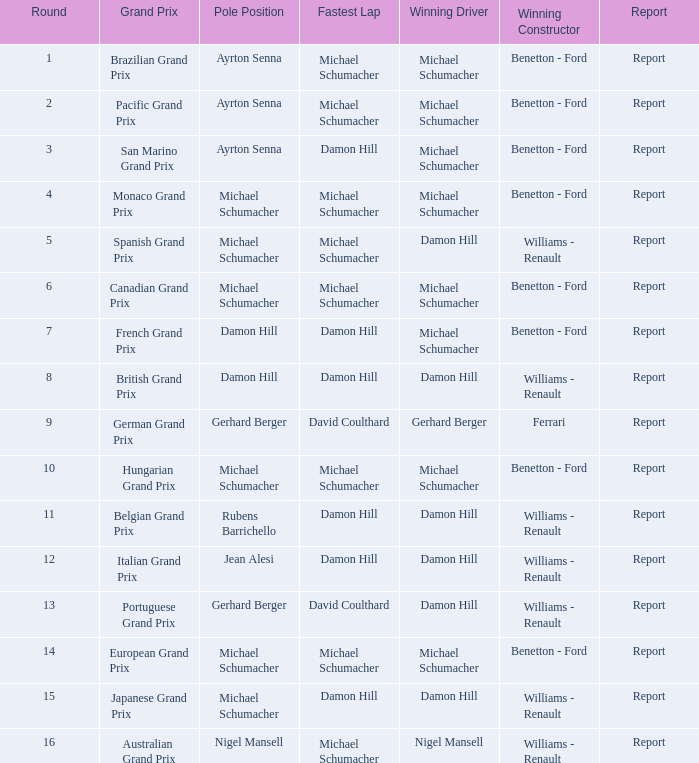Name the lowest round for when pole position and winning driver is michael schumacher 4.0. 